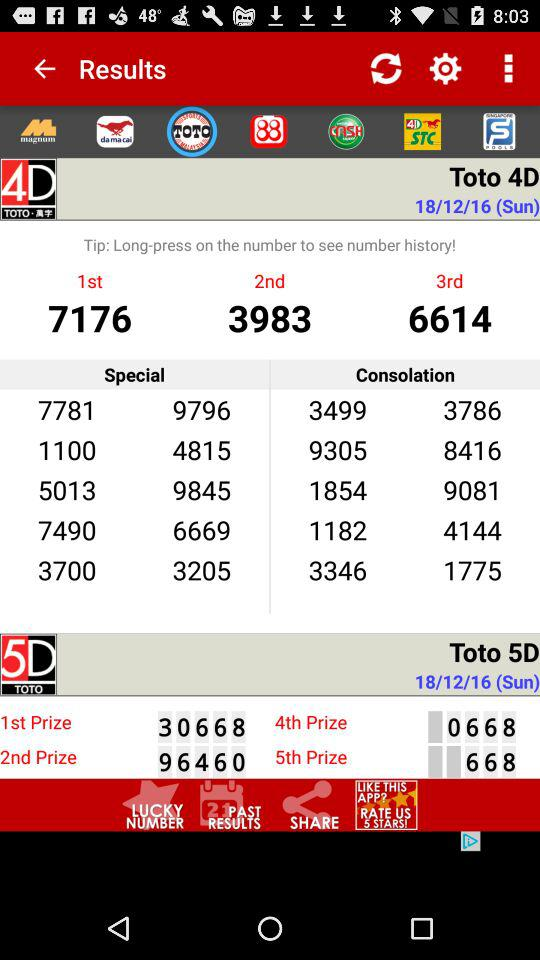What is the number for the second prize in "Toto 5D"? The number is 96460. 